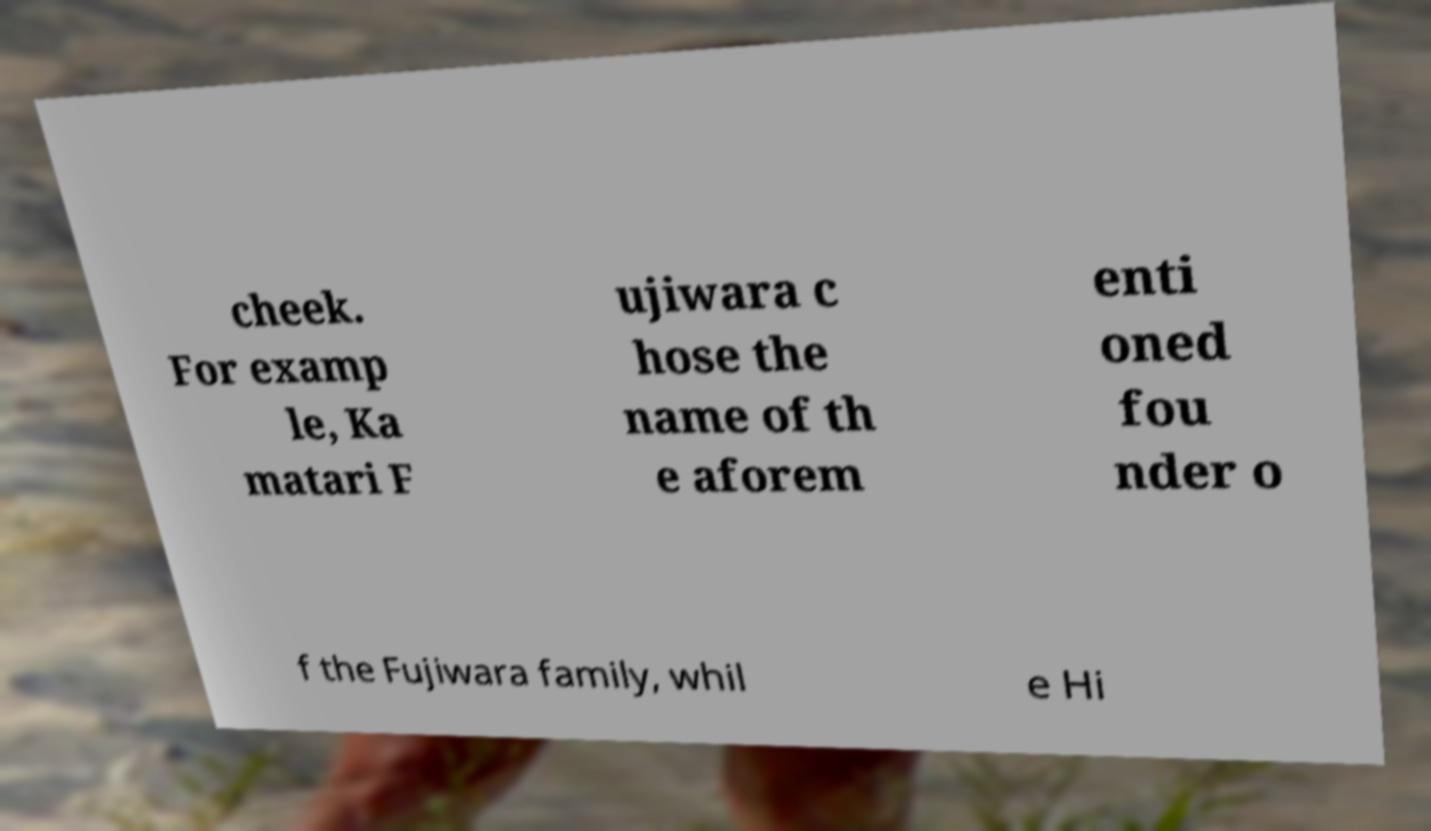I need the written content from this picture converted into text. Can you do that? cheek. For examp le, Ka matari F ujiwara c hose the name of th e aforem enti oned fou nder o f the Fujiwara family, whil e Hi 